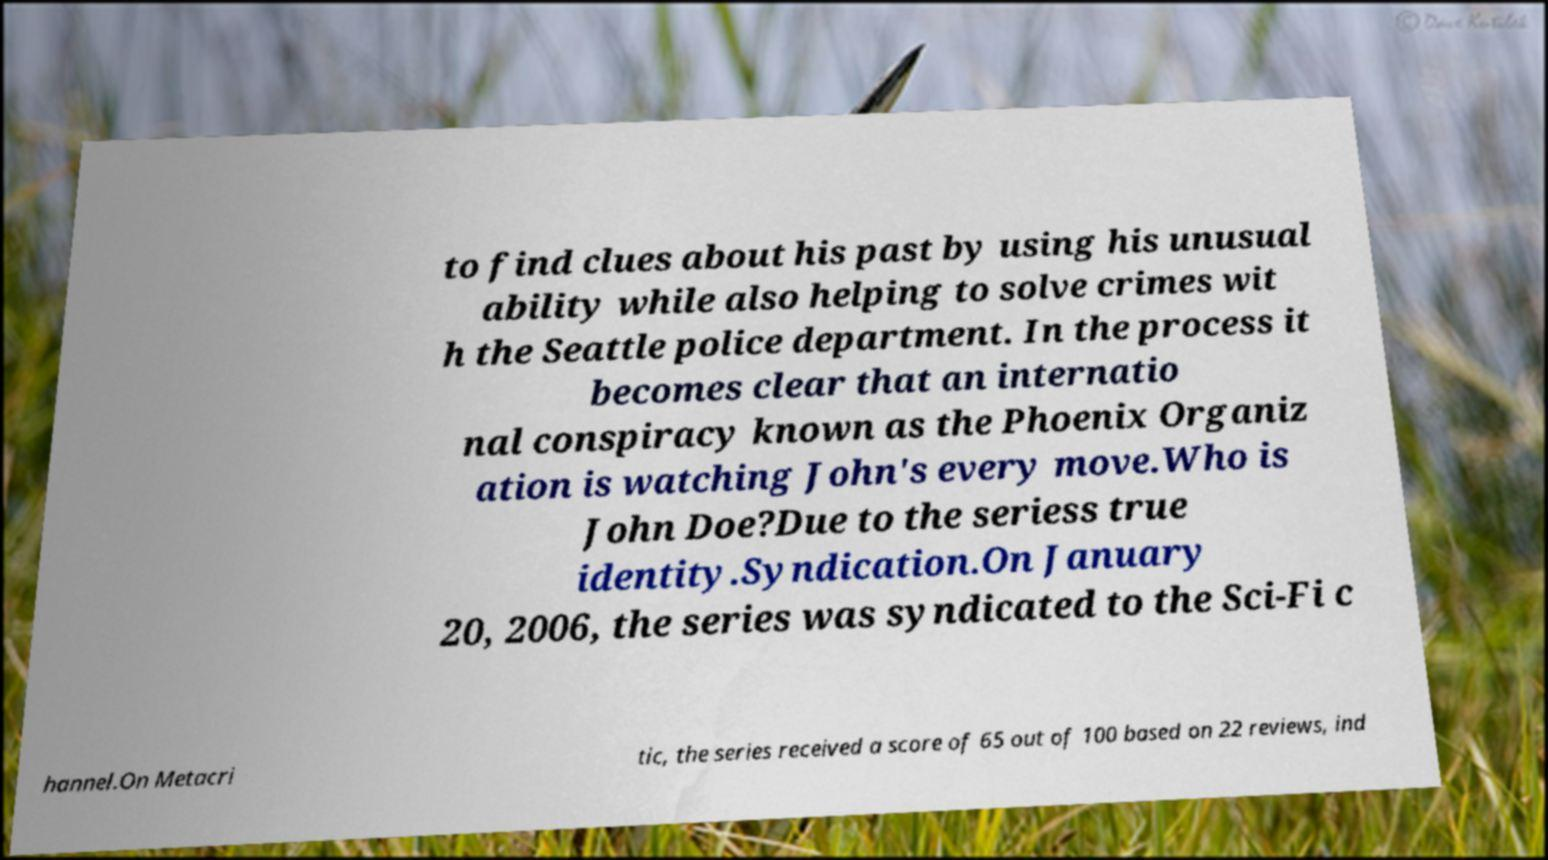For documentation purposes, I need the text within this image transcribed. Could you provide that? to find clues about his past by using his unusual ability while also helping to solve crimes wit h the Seattle police department. In the process it becomes clear that an internatio nal conspiracy known as the Phoenix Organiz ation is watching John's every move.Who is John Doe?Due to the seriess true identity.Syndication.On January 20, 2006, the series was syndicated to the Sci-Fi c hannel.On Metacri tic, the series received a score of 65 out of 100 based on 22 reviews, ind 